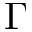Convert formula to latex. <formula><loc_0><loc_0><loc_500><loc_500>\Gamma</formula> 